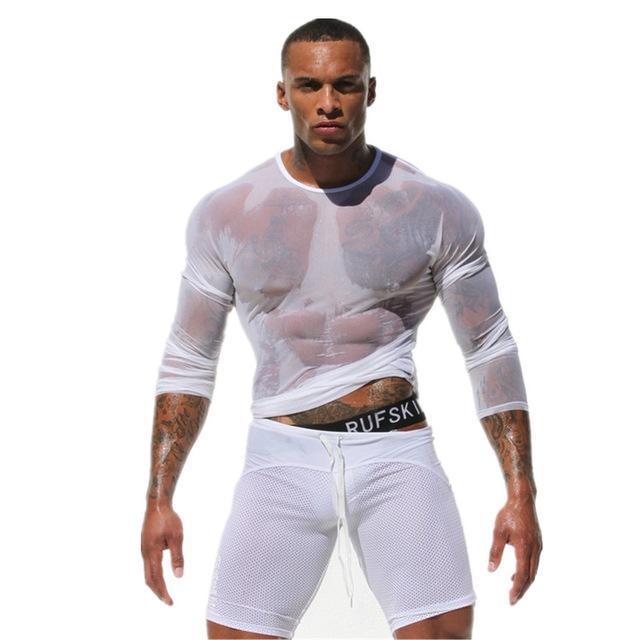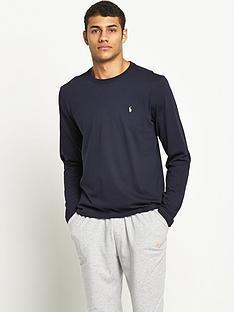The first image is the image on the left, the second image is the image on the right. For the images displayed, is the sentence "The model on the right wears plaid bottoms and a dark, solid-colored top." factually correct? Answer yes or no. No. The first image is the image on the left, the second image is the image on the right. Assess this claim about the two images: "All photos are full length shots of people modeling clothes.". Correct or not? Answer yes or no. No. 